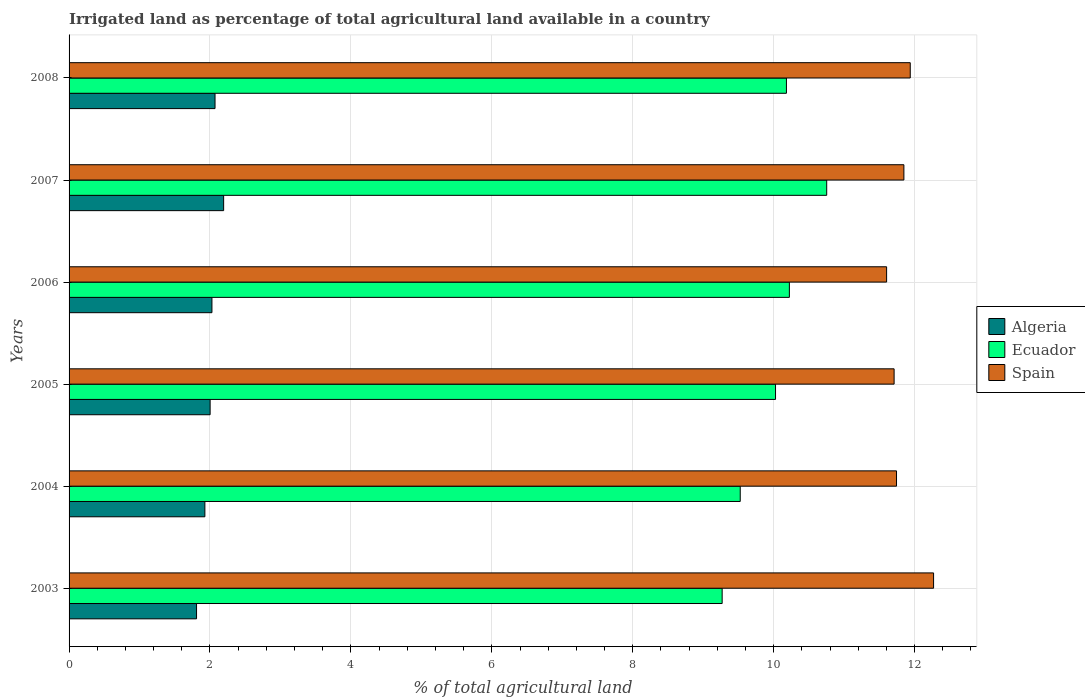Are the number of bars per tick equal to the number of legend labels?
Provide a short and direct response. Yes. What is the label of the 2nd group of bars from the top?
Make the answer very short. 2007. What is the percentage of irrigated land in Ecuador in 2003?
Your answer should be very brief. 9.27. Across all years, what is the maximum percentage of irrigated land in Algeria?
Provide a short and direct response. 2.19. Across all years, what is the minimum percentage of irrigated land in Ecuador?
Offer a terse response. 9.27. In which year was the percentage of irrigated land in Spain maximum?
Give a very brief answer. 2003. In which year was the percentage of irrigated land in Algeria minimum?
Provide a succinct answer. 2003. What is the total percentage of irrigated land in Algeria in the graph?
Your answer should be very brief. 12.03. What is the difference between the percentage of irrigated land in Algeria in 2004 and that in 2007?
Your response must be concise. -0.27. What is the difference between the percentage of irrigated land in Ecuador in 2006 and the percentage of irrigated land in Spain in 2003?
Ensure brevity in your answer.  -2.05. What is the average percentage of irrigated land in Algeria per year?
Ensure brevity in your answer.  2.01. In the year 2008, what is the difference between the percentage of irrigated land in Ecuador and percentage of irrigated land in Spain?
Make the answer very short. -1.76. In how many years, is the percentage of irrigated land in Algeria greater than 4.4 %?
Make the answer very short. 0. What is the ratio of the percentage of irrigated land in Algeria in 2005 to that in 2008?
Keep it short and to the point. 0.97. What is the difference between the highest and the second highest percentage of irrigated land in Ecuador?
Make the answer very short. 0.53. What is the difference between the highest and the lowest percentage of irrigated land in Spain?
Ensure brevity in your answer.  0.67. Is the sum of the percentage of irrigated land in Spain in 2005 and 2006 greater than the maximum percentage of irrigated land in Ecuador across all years?
Ensure brevity in your answer.  Yes. What does the 3rd bar from the top in 2007 represents?
Ensure brevity in your answer.  Algeria. What does the 3rd bar from the bottom in 2007 represents?
Keep it short and to the point. Spain. How many years are there in the graph?
Your answer should be very brief. 6. Are the values on the major ticks of X-axis written in scientific E-notation?
Ensure brevity in your answer.  No. How many legend labels are there?
Provide a succinct answer. 3. What is the title of the graph?
Your response must be concise. Irrigated land as percentage of total agricultural land available in a country. What is the label or title of the X-axis?
Keep it short and to the point. % of total agricultural land. What is the label or title of the Y-axis?
Keep it short and to the point. Years. What is the % of total agricultural land of Algeria in 2003?
Provide a short and direct response. 1.81. What is the % of total agricultural land in Ecuador in 2003?
Your response must be concise. 9.27. What is the % of total agricultural land in Spain in 2003?
Offer a terse response. 12.27. What is the % of total agricultural land in Algeria in 2004?
Your answer should be very brief. 1.93. What is the % of total agricultural land in Ecuador in 2004?
Ensure brevity in your answer.  9.53. What is the % of total agricultural land of Spain in 2004?
Your answer should be very brief. 11.74. What is the % of total agricultural land in Algeria in 2005?
Keep it short and to the point. 2. What is the % of total agricultural land in Ecuador in 2005?
Make the answer very short. 10.03. What is the % of total agricultural land in Spain in 2005?
Offer a terse response. 11.71. What is the % of total agricultural land of Algeria in 2006?
Offer a terse response. 2.03. What is the % of total agricultural land of Ecuador in 2006?
Give a very brief answer. 10.22. What is the % of total agricultural land in Spain in 2006?
Provide a succinct answer. 11.6. What is the % of total agricultural land of Algeria in 2007?
Your answer should be compact. 2.19. What is the % of total agricultural land in Ecuador in 2007?
Provide a succinct answer. 10.75. What is the % of total agricultural land of Spain in 2007?
Make the answer very short. 11.85. What is the % of total agricultural land in Algeria in 2008?
Offer a very short reply. 2.07. What is the % of total agricultural land in Ecuador in 2008?
Provide a short and direct response. 10.18. What is the % of total agricultural land of Spain in 2008?
Provide a succinct answer. 11.94. Across all years, what is the maximum % of total agricultural land in Algeria?
Your answer should be compact. 2.19. Across all years, what is the maximum % of total agricultural land in Ecuador?
Your answer should be very brief. 10.75. Across all years, what is the maximum % of total agricultural land in Spain?
Provide a succinct answer. 12.27. Across all years, what is the minimum % of total agricultural land of Algeria?
Offer a terse response. 1.81. Across all years, what is the minimum % of total agricultural land of Ecuador?
Ensure brevity in your answer.  9.27. Across all years, what is the minimum % of total agricultural land in Spain?
Keep it short and to the point. 11.6. What is the total % of total agricultural land of Algeria in the graph?
Offer a very short reply. 12.03. What is the total % of total agricultural land of Ecuador in the graph?
Offer a very short reply. 59.98. What is the total % of total agricultural land of Spain in the graph?
Keep it short and to the point. 71.11. What is the difference between the % of total agricultural land of Algeria in 2003 and that in 2004?
Keep it short and to the point. -0.12. What is the difference between the % of total agricultural land of Ecuador in 2003 and that in 2004?
Offer a terse response. -0.26. What is the difference between the % of total agricultural land in Spain in 2003 and that in 2004?
Keep it short and to the point. 0.53. What is the difference between the % of total agricultural land in Algeria in 2003 and that in 2005?
Ensure brevity in your answer.  -0.19. What is the difference between the % of total agricultural land in Ecuador in 2003 and that in 2005?
Make the answer very short. -0.76. What is the difference between the % of total agricultural land of Spain in 2003 and that in 2005?
Keep it short and to the point. 0.56. What is the difference between the % of total agricultural land of Algeria in 2003 and that in 2006?
Your answer should be compact. -0.22. What is the difference between the % of total agricultural land of Ecuador in 2003 and that in 2006?
Make the answer very short. -0.95. What is the difference between the % of total agricultural land in Spain in 2003 and that in 2006?
Provide a short and direct response. 0.67. What is the difference between the % of total agricultural land of Algeria in 2003 and that in 2007?
Give a very brief answer. -0.38. What is the difference between the % of total agricultural land of Ecuador in 2003 and that in 2007?
Offer a terse response. -1.48. What is the difference between the % of total agricultural land in Spain in 2003 and that in 2007?
Your response must be concise. 0.42. What is the difference between the % of total agricultural land in Algeria in 2003 and that in 2008?
Your response must be concise. -0.26. What is the difference between the % of total agricultural land in Ecuador in 2003 and that in 2008?
Your response must be concise. -0.91. What is the difference between the % of total agricultural land of Spain in 2003 and that in 2008?
Give a very brief answer. 0.33. What is the difference between the % of total agricultural land in Algeria in 2004 and that in 2005?
Your response must be concise. -0.07. What is the difference between the % of total agricultural land in Ecuador in 2004 and that in 2005?
Offer a terse response. -0.5. What is the difference between the % of total agricultural land in Spain in 2004 and that in 2005?
Give a very brief answer. 0.03. What is the difference between the % of total agricultural land of Algeria in 2004 and that in 2006?
Your answer should be very brief. -0.1. What is the difference between the % of total agricultural land in Ecuador in 2004 and that in 2006?
Offer a terse response. -0.7. What is the difference between the % of total agricultural land of Spain in 2004 and that in 2006?
Provide a succinct answer. 0.14. What is the difference between the % of total agricultural land in Algeria in 2004 and that in 2007?
Keep it short and to the point. -0.27. What is the difference between the % of total agricultural land in Ecuador in 2004 and that in 2007?
Ensure brevity in your answer.  -1.23. What is the difference between the % of total agricultural land of Spain in 2004 and that in 2007?
Offer a very short reply. -0.1. What is the difference between the % of total agricultural land of Algeria in 2004 and that in 2008?
Offer a terse response. -0.14. What is the difference between the % of total agricultural land of Ecuador in 2004 and that in 2008?
Provide a succinct answer. -0.66. What is the difference between the % of total agricultural land in Spain in 2004 and that in 2008?
Offer a terse response. -0.2. What is the difference between the % of total agricultural land of Algeria in 2005 and that in 2006?
Make the answer very short. -0.03. What is the difference between the % of total agricultural land of Ecuador in 2005 and that in 2006?
Make the answer very short. -0.2. What is the difference between the % of total agricultural land of Spain in 2005 and that in 2006?
Your answer should be very brief. 0.11. What is the difference between the % of total agricultural land in Algeria in 2005 and that in 2007?
Keep it short and to the point. -0.19. What is the difference between the % of total agricultural land of Ecuador in 2005 and that in 2007?
Ensure brevity in your answer.  -0.73. What is the difference between the % of total agricultural land in Spain in 2005 and that in 2007?
Give a very brief answer. -0.14. What is the difference between the % of total agricultural land of Algeria in 2005 and that in 2008?
Provide a short and direct response. -0.07. What is the difference between the % of total agricultural land of Ecuador in 2005 and that in 2008?
Make the answer very short. -0.15. What is the difference between the % of total agricultural land of Spain in 2005 and that in 2008?
Offer a very short reply. -0.23. What is the difference between the % of total agricultural land of Algeria in 2006 and that in 2007?
Offer a terse response. -0.17. What is the difference between the % of total agricultural land of Ecuador in 2006 and that in 2007?
Keep it short and to the point. -0.53. What is the difference between the % of total agricultural land of Spain in 2006 and that in 2007?
Offer a very short reply. -0.25. What is the difference between the % of total agricultural land of Algeria in 2006 and that in 2008?
Your answer should be very brief. -0.04. What is the difference between the % of total agricultural land in Ecuador in 2006 and that in 2008?
Make the answer very short. 0.04. What is the difference between the % of total agricultural land of Spain in 2006 and that in 2008?
Your answer should be compact. -0.34. What is the difference between the % of total agricultural land in Algeria in 2007 and that in 2008?
Ensure brevity in your answer.  0.12. What is the difference between the % of total agricultural land in Ecuador in 2007 and that in 2008?
Ensure brevity in your answer.  0.57. What is the difference between the % of total agricultural land of Spain in 2007 and that in 2008?
Give a very brief answer. -0.09. What is the difference between the % of total agricultural land of Algeria in 2003 and the % of total agricultural land of Ecuador in 2004?
Provide a succinct answer. -7.72. What is the difference between the % of total agricultural land of Algeria in 2003 and the % of total agricultural land of Spain in 2004?
Give a very brief answer. -9.93. What is the difference between the % of total agricultural land in Ecuador in 2003 and the % of total agricultural land in Spain in 2004?
Offer a very short reply. -2.47. What is the difference between the % of total agricultural land in Algeria in 2003 and the % of total agricultural land in Ecuador in 2005?
Ensure brevity in your answer.  -8.22. What is the difference between the % of total agricultural land of Algeria in 2003 and the % of total agricultural land of Spain in 2005?
Your answer should be compact. -9.9. What is the difference between the % of total agricultural land in Ecuador in 2003 and the % of total agricultural land in Spain in 2005?
Your answer should be very brief. -2.44. What is the difference between the % of total agricultural land in Algeria in 2003 and the % of total agricultural land in Ecuador in 2006?
Your response must be concise. -8.41. What is the difference between the % of total agricultural land in Algeria in 2003 and the % of total agricultural land in Spain in 2006?
Make the answer very short. -9.79. What is the difference between the % of total agricultural land in Ecuador in 2003 and the % of total agricultural land in Spain in 2006?
Your response must be concise. -2.33. What is the difference between the % of total agricultural land in Algeria in 2003 and the % of total agricultural land in Ecuador in 2007?
Provide a succinct answer. -8.94. What is the difference between the % of total agricultural land of Algeria in 2003 and the % of total agricultural land of Spain in 2007?
Keep it short and to the point. -10.04. What is the difference between the % of total agricultural land in Ecuador in 2003 and the % of total agricultural land in Spain in 2007?
Provide a succinct answer. -2.58. What is the difference between the % of total agricultural land of Algeria in 2003 and the % of total agricultural land of Ecuador in 2008?
Your answer should be very brief. -8.37. What is the difference between the % of total agricultural land of Algeria in 2003 and the % of total agricultural land of Spain in 2008?
Your response must be concise. -10.13. What is the difference between the % of total agricultural land of Ecuador in 2003 and the % of total agricultural land of Spain in 2008?
Ensure brevity in your answer.  -2.67. What is the difference between the % of total agricultural land of Algeria in 2004 and the % of total agricultural land of Ecuador in 2005?
Your answer should be compact. -8.1. What is the difference between the % of total agricultural land in Algeria in 2004 and the % of total agricultural land in Spain in 2005?
Provide a short and direct response. -9.78. What is the difference between the % of total agricultural land in Ecuador in 2004 and the % of total agricultural land in Spain in 2005?
Provide a succinct answer. -2.18. What is the difference between the % of total agricultural land of Algeria in 2004 and the % of total agricultural land of Ecuador in 2006?
Provide a short and direct response. -8.3. What is the difference between the % of total agricultural land of Algeria in 2004 and the % of total agricultural land of Spain in 2006?
Offer a very short reply. -9.68. What is the difference between the % of total agricultural land of Ecuador in 2004 and the % of total agricultural land of Spain in 2006?
Provide a succinct answer. -2.08. What is the difference between the % of total agricultural land of Algeria in 2004 and the % of total agricultural land of Ecuador in 2007?
Provide a succinct answer. -8.83. What is the difference between the % of total agricultural land in Algeria in 2004 and the % of total agricultural land in Spain in 2007?
Your response must be concise. -9.92. What is the difference between the % of total agricultural land in Ecuador in 2004 and the % of total agricultural land in Spain in 2007?
Provide a succinct answer. -2.32. What is the difference between the % of total agricultural land of Algeria in 2004 and the % of total agricultural land of Ecuador in 2008?
Your response must be concise. -8.25. What is the difference between the % of total agricultural land in Algeria in 2004 and the % of total agricultural land in Spain in 2008?
Your answer should be compact. -10.01. What is the difference between the % of total agricultural land in Ecuador in 2004 and the % of total agricultural land in Spain in 2008?
Offer a terse response. -2.41. What is the difference between the % of total agricultural land in Algeria in 2005 and the % of total agricultural land in Ecuador in 2006?
Provide a short and direct response. -8.22. What is the difference between the % of total agricultural land in Algeria in 2005 and the % of total agricultural land in Spain in 2006?
Your response must be concise. -9.6. What is the difference between the % of total agricultural land of Ecuador in 2005 and the % of total agricultural land of Spain in 2006?
Give a very brief answer. -1.58. What is the difference between the % of total agricultural land in Algeria in 2005 and the % of total agricultural land in Ecuador in 2007?
Provide a succinct answer. -8.75. What is the difference between the % of total agricultural land of Algeria in 2005 and the % of total agricultural land of Spain in 2007?
Ensure brevity in your answer.  -9.85. What is the difference between the % of total agricultural land in Ecuador in 2005 and the % of total agricultural land in Spain in 2007?
Ensure brevity in your answer.  -1.82. What is the difference between the % of total agricultural land of Algeria in 2005 and the % of total agricultural land of Ecuador in 2008?
Your answer should be very brief. -8.18. What is the difference between the % of total agricultural land in Algeria in 2005 and the % of total agricultural land in Spain in 2008?
Offer a very short reply. -9.94. What is the difference between the % of total agricultural land of Ecuador in 2005 and the % of total agricultural land of Spain in 2008?
Keep it short and to the point. -1.91. What is the difference between the % of total agricultural land in Algeria in 2006 and the % of total agricultural land in Ecuador in 2007?
Make the answer very short. -8.73. What is the difference between the % of total agricultural land in Algeria in 2006 and the % of total agricultural land in Spain in 2007?
Your answer should be very brief. -9.82. What is the difference between the % of total agricultural land in Ecuador in 2006 and the % of total agricultural land in Spain in 2007?
Your response must be concise. -1.63. What is the difference between the % of total agricultural land of Algeria in 2006 and the % of total agricultural land of Ecuador in 2008?
Your response must be concise. -8.15. What is the difference between the % of total agricultural land in Algeria in 2006 and the % of total agricultural land in Spain in 2008?
Offer a very short reply. -9.91. What is the difference between the % of total agricultural land of Ecuador in 2006 and the % of total agricultural land of Spain in 2008?
Your response must be concise. -1.72. What is the difference between the % of total agricultural land of Algeria in 2007 and the % of total agricultural land of Ecuador in 2008?
Make the answer very short. -7.99. What is the difference between the % of total agricultural land of Algeria in 2007 and the % of total agricultural land of Spain in 2008?
Keep it short and to the point. -9.74. What is the difference between the % of total agricultural land in Ecuador in 2007 and the % of total agricultural land in Spain in 2008?
Your answer should be very brief. -1.19. What is the average % of total agricultural land in Algeria per year?
Give a very brief answer. 2.01. What is the average % of total agricultural land in Ecuador per year?
Your answer should be very brief. 10. What is the average % of total agricultural land of Spain per year?
Give a very brief answer. 11.85. In the year 2003, what is the difference between the % of total agricultural land in Algeria and % of total agricultural land in Ecuador?
Your response must be concise. -7.46. In the year 2003, what is the difference between the % of total agricultural land in Algeria and % of total agricultural land in Spain?
Provide a succinct answer. -10.46. In the year 2003, what is the difference between the % of total agricultural land in Ecuador and % of total agricultural land in Spain?
Give a very brief answer. -3. In the year 2004, what is the difference between the % of total agricultural land in Algeria and % of total agricultural land in Ecuador?
Keep it short and to the point. -7.6. In the year 2004, what is the difference between the % of total agricultural land in Algeria and % of total agricultural land in Spain?
Your response must be concise. -9.82. In the year 2004, what is the difference between the % of total agricultural land of Ecuador and % of total agricultural land of Spain?
Keep it short and to the point. -2.22. In the year 2005, what is the difference between the % of total agricultural land in Algeria and % of total agricultural land in Ecuador?
Make the answer very short. -8.02. In the year 2005, what is the difference between the % of total agricultural land of Algeria and % of total agricultural land of Spain?
Your answer should be very brief. -9.71. In the year 2005, what is the difference between the % of total agricultural land of Ecuador and % of total agricultural land of Spain?
Your response must be concise. -1.68. In the year 2006, what is the difference between the % of total agricultural land in Algeria and % of total agricultural land in Ecuador?
Provide a succinct answer. -8.2. In the year 2006, what is the difference between the % of total agricultural land in Algeria and % of total agricultural land in Spain?
Ensure brevity in your answer.  -9.58. In the year 2006, what is the difference between the % of total agricultural land of Ecuador and % of total agricultural land of Spain?
Give a very brief answer. -1.38. In the year 2007, what is the difference between the % of total agricultural land in Algeria and % of total agricultural land in Ecuador?
Your response must be concise. -8.56. In the year 2007, what is the difference between the % of total agricultural land in Algeria and % of total agricultural land in Spain?
Keep it short and to the point. -9.65. In the year 2007, what is the difference between the % of total agricultural land in Ecuador and % of total agricultural land in Spain?
Offer a very short reply. -1.1. In the year 2008, what is the difference between the % of total agricultural land of Algeria and % of total agricultural land of Ecuador?
Make the answer very short. -8.11. In the year 2008, what is the difference between the % of total agricultural land of Algeria and % of total agricultural land of Spain?
Provide a succinct answer. -9.87. In the year 2008, what is the difference between the % of total agricultural land in Ecuador and % of total agricultural land in Spain?
Your answer should be very brief. -1.76. What is the ratio of the % of total agricultural land in Algeria in 2003 to that in 2004?
Provide a succinct answer. 0.94. What is the ratio of the % of total agricultural land of Ecuador in 2003 to that in 2004?
Provide a succinct answer. 0.97. What is the ratio of the % of total agricultural land in Spain in 2003 to that in 2004?
Your answer should be very brief. 1.04. What is the ratio of the % of total agricultural land in Algeria in 2003 to that in 2005?
Your response must be concise. 0.9. What is the ratio of the % of total agricultural land of Ecuador in 2003 to that in 2005?
Provide a succinct answer. 0.92. What is the ratio of the % of total agricultural land in Spain in 2003 to that in 2005?
Give a very brief answer. 1.05. What is the ratio of the % of total agricultural land of Algeria in 2003 to that in 2006?
Offer a very short reply. 0.89. What is the ratio of the % of total agricultural land of Ecuador in 2003 to that in 2006?
Ensure brevity in your answer.  0.91. What is the ratio of the % of total agricultural land of Spain in 2003 to that in 2006?
Your response must be concise. 1.06. What is the ratio of the % of total agricultural land in Algeria in 2003 to that in 2007?
Keep it short and to the point. 0.82. What is the ratio of the % of total agricultural land in Ecuador in 2003 to that in 2007?
Offer a terse response. 0.86. What is the ratio of the % of total agricultural land of Spain in 2003 to that in 2007?
Ensure brevity in your answer.  1.04. What is the ratio of the % of total agricultural land of Algeria in 2003 to that in 2008?
Provide a succinct answer. 0.87. What is the ratio of the % of total agricultural land in Ecuador in 2003 to that in 2008?
Your answer should be very brief. 0.91. What is the ratio of the % of total agricultural land in Spain in 2003 to that in 2008?
Your answer should be very brief. 1.03. What is the ratio of the % of total agricultural land in Algeria in 2004 to that in 2005?
Your answer should be very brief. 0.96. What is the ratio of the % of total agricultural land in Spain in 2004 to that in 2005?
Provide a short and direct response. 1. What is the ratio of the % of total agricultural land of Algeria in 2004 to that in 2006?
Provide a short and direct response. 0.95. What is the ratio of the % of total agricultural land in Ecuador in 2004 to that in 2006?
Offer a very short reply. 0.93. What is the ratio of the % of total agricultural land in Spain in 2004 to that in 2006?
Offer a terse response. 1.01. What is the ratio of the % of total agricultural land in Algeria in 2004 to that in 2007?
Your answer should be compact. 0.88. What is the ratio of the % of total agricultural land in Ecuador in 2004 to that in 2007?
Offer a terse response. 0.89. What is the ratio of the % of total agricultural land of Algeria in 2004 to that in 2008?
Offer a very short reply. 0.93. What is the ratio of the % of total agricultural land of Ecuador in 2004 to that in 2008?
Provide a short and direct response. 0.94. What is the ratio of the % of total agricultural land of Spain in 2004 to that in 2008?
Offer a terse response. 0.98. What is the ratio of the % of total agricultural land of Algeria in 2005 to that in 2006?
Keep it short and to the point. 0.99. What is the ratio of the % of total agricultural land of Ecuador in 2005 to that in 2006?
Offer a terse response. 0.98. What is the ratio of the % of total agricultural land in Spain in 2005 to that in 2006?
Ensure brevity in your answer.  1.01. What is the ratio of the % of total agricultural land in Algeria in 2005 to that in 2007?
Offer a very short reply. 0.91. What is the ratio of the % of total agricultural land of Ecuador in 2005 to that in 2007?
Keep it short and to the point. 0.93. What is the ratio of the % of total agricultural land of Spain in 2005 to that in 2007?
Make the answer very short. 0.99. What is the ratio of the % of total agricultural land of Algeria in 2005 to that in 2008?
Make the answer very short. 0.97. What is the ratio of the % of total agricultural land of Spain in 2005 to that in 2008?
Provide a short and direct response. 0.98. What is the ratio of the % of total agricultural land in Algeria in 2006 to that in 2007?
Give a very brief answer. 0.92. What is the ratio of the % of total agricultural land of Ecuador in 2006 to that in 2007?
Offer a terse response. 0.95. What is the ratio of the % of total agricultural land in Spain in 2006 to that in 2007?
Offer a very short reply. 0.98. What is the ratio of the % of total agricultural land of Algeria in 2006 to that in 2008?
Your answer should be compact. 0.98. What is the ratio of the % of total agricultural land of Ecuador in 2006 to that in 2008?
Provide a succinct answer. 1. What is the ratio of the % of total agricultural land in Spain in 2006 to that in 2008?
Give a very brief answer. 0.97. What is the ratio of the % of total agricultural land in Algeria in 2007 to that in 2008?
Provide a short and direct response. 1.06. What is the ratio of the % of total agricultural land of Ecuador in 2007 to that in 2008?
Offer a very short reply. 1.06. What is the ratio of the % of total agricultural land in Spain in 2007 to that in 2008?
Offer a terse response. 0.99. What is the difference between the highest and the second highest % of total agricultural land of Algeria?
Provide a succinct answer. 0.12. What is the difference between the highest and the second highest % of total agricultural land in Ecuador?
Provide a succinct answer. 0.53. What is the difference between the highest and the second highest % of total agricultural land of Spain?
Ensure brevity in your answer.  0.33. What is the difference between the highest and the lowest % of total agricultural land of Algeria?
Make the answer very short. 0.38. What is the difference between the highest and the lowest % of total agricultural land of Ecuador?
Offer a terse response. 1.48. What is the difference between the highest and the lowest % of total agricultural land in Spain?
Your answer should be very brief. 0.67. 